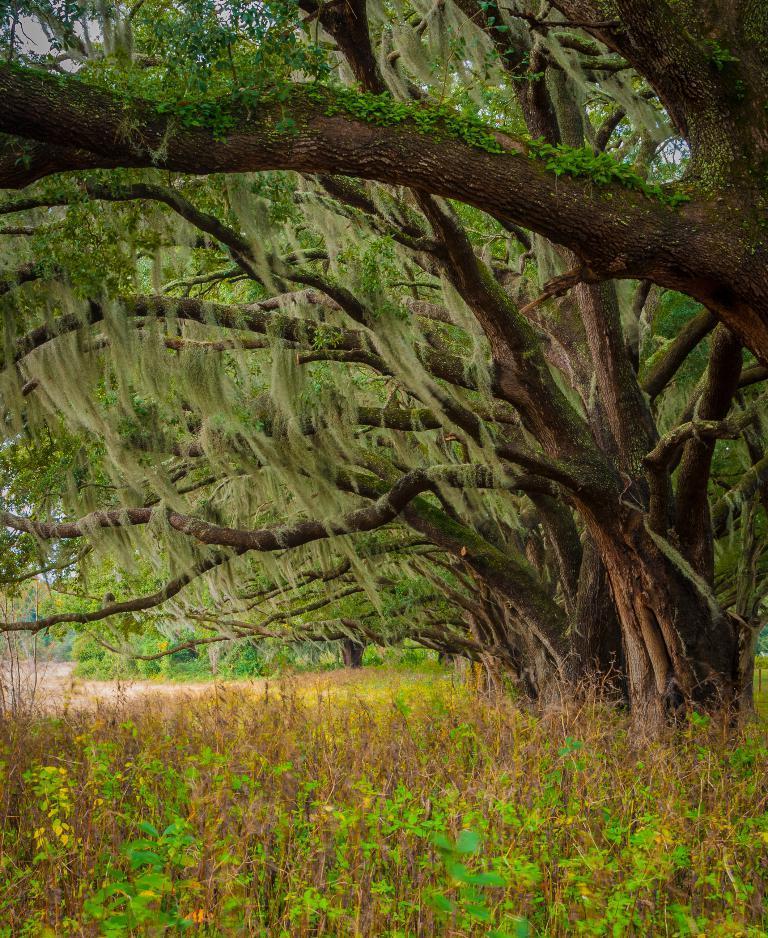Describe this image in one or two sentences. In this image we can see trees, sky and plants. 